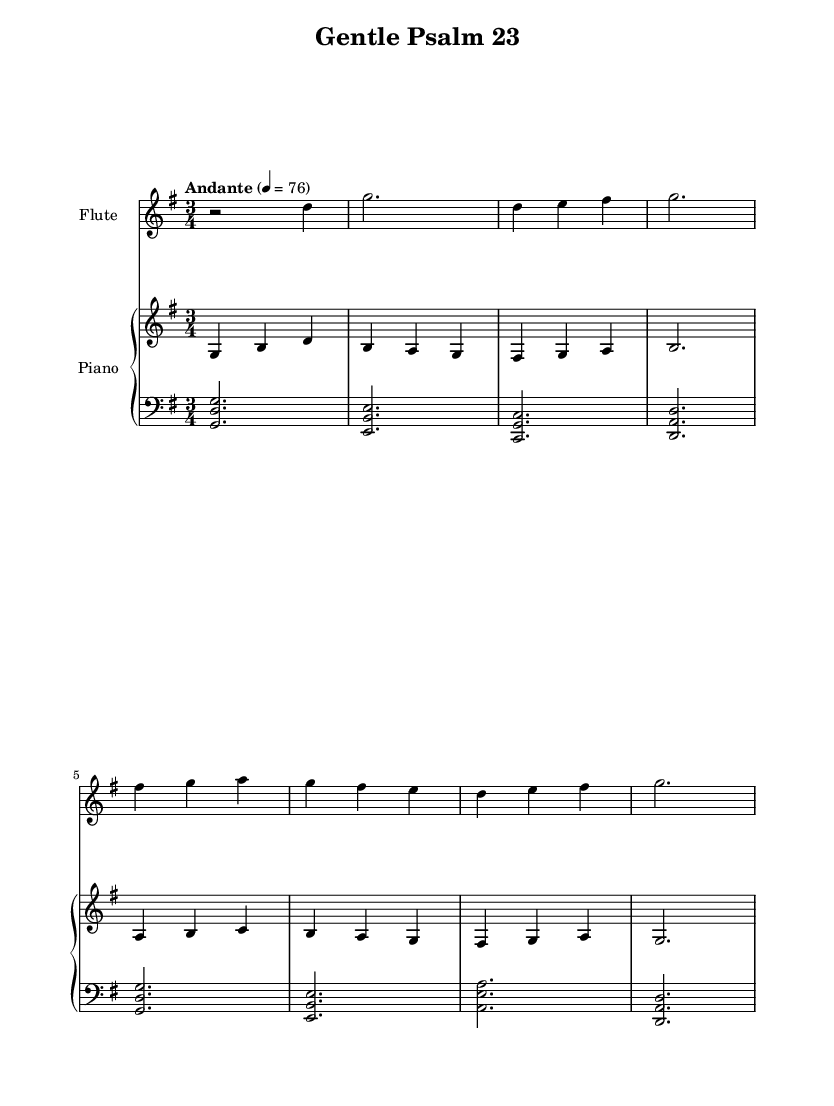What is the key signature of this music? The key signature is G major, which has one sharp (F#). This can be identified by looking at the key signature section, which is usually placed at the beginning of the staff.
Answer: G major What is the time signature of this music? The time signature is 3/4, indicated by the two numbers at the beginning of the score. The top number shows that there are three beats in each measure, and the bottom number indicates that each beat is a quarter note.
Answer: 3/4 What is the indicated tempo for this piece? The tempo is marked as "Andante" with a metronome marking of 76. This information is usually found near the top of the score, indicating the speed of the music.
Answer: Andante 76 How many measures are in the score? There are eight measures in this score. You can count the vertical lines (barlines) that separate the measures to arrive at this number.
Answer: Eight Which instrument plays the melody? The flute plays the melody, as indicated by the instrument name at the top of the staff where the flute notation is written.
Answer: Flute What type of piece is this music? This music is a gentle instrumental rendition of a psalm, specifically Psalm 23. This can be inferred from the title given in the header of the score, which references a traditional religious text.
Answer: Psalm 23 